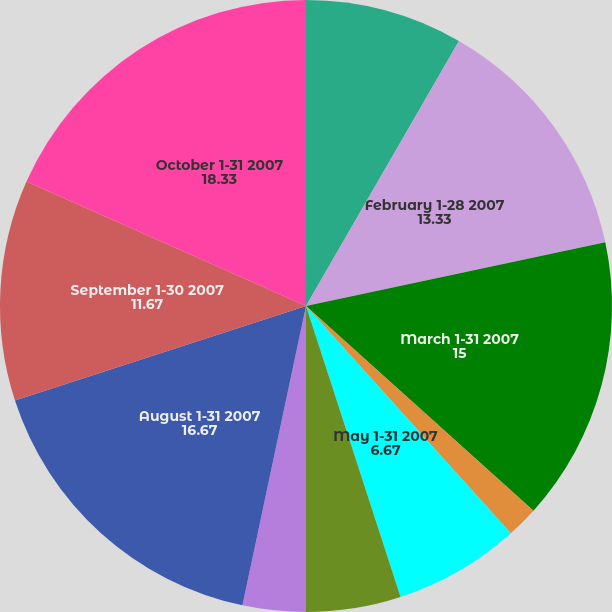Convert chart. <chart><loc_0><loc_0><loc_500><loc_500><pie_chart><fcel>January 1-31 2007<fcel>February 1-28 2007<fcel>March 1-31 2007<fcel>April 1-30 2007<fcel>May 1-31 2007<fcel>June 1-30 2007<fcel>July 1-31 2007<fcel>August 1-31 2007<fcel>September 1-30 2007<fcel>October 1-31 2007<nl><fcel>8.33%<fcel>13.33%<fcel>15.0%<fcel>1.67%<fcel>6.67%<fcel>5.0%<fcel>3.33%<fcel>16.67%<fcel>11.67%<fcel>18.33%<nl></chart> 